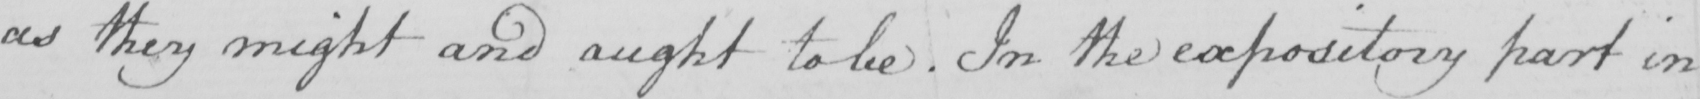Please provide the text content of this handwritten line. as they might and aught to be . In the expository part in 